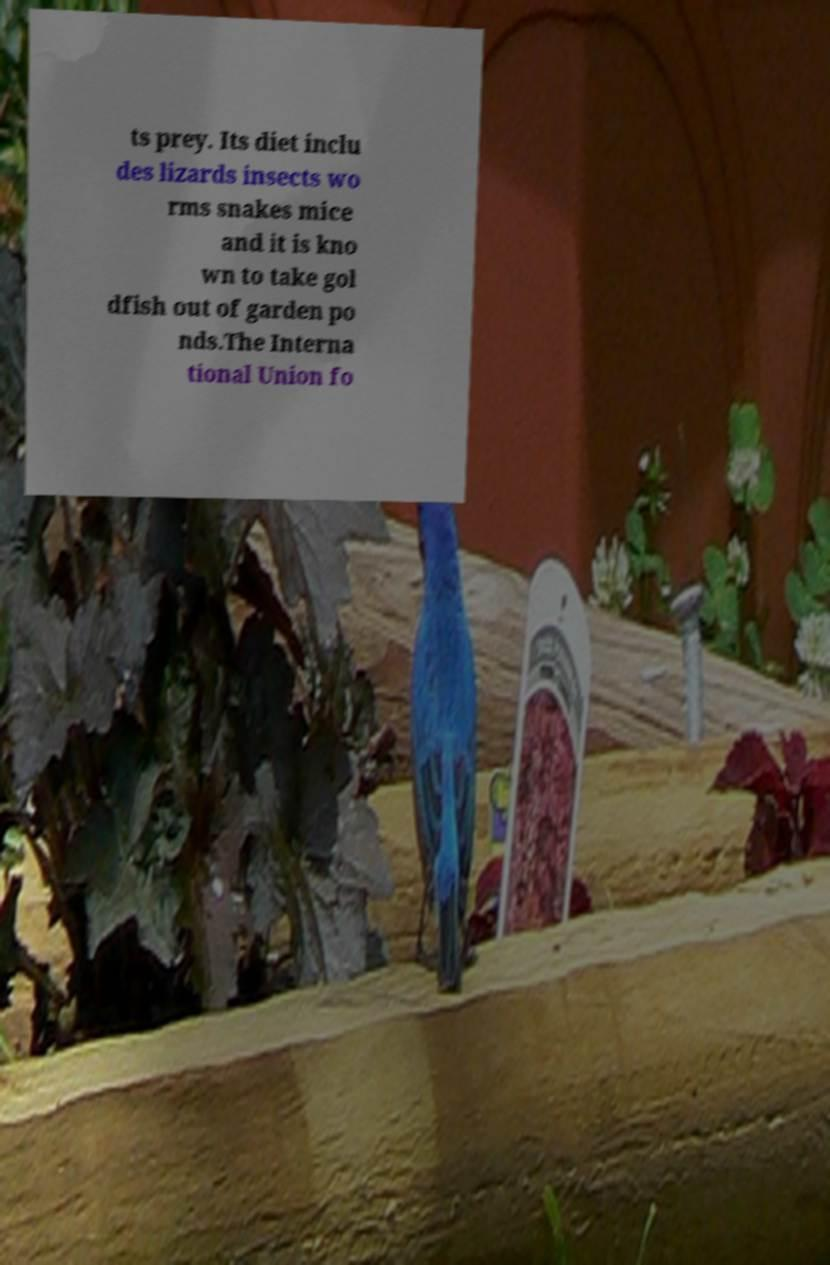Could you assist in decoding the text presented in this image and type it out clearly? ts prey. Its diet inclu des lizards insects wo rms snakes mice and it is kno wn to take gol dfish out of garden po nds.The Interna tional Union fo 